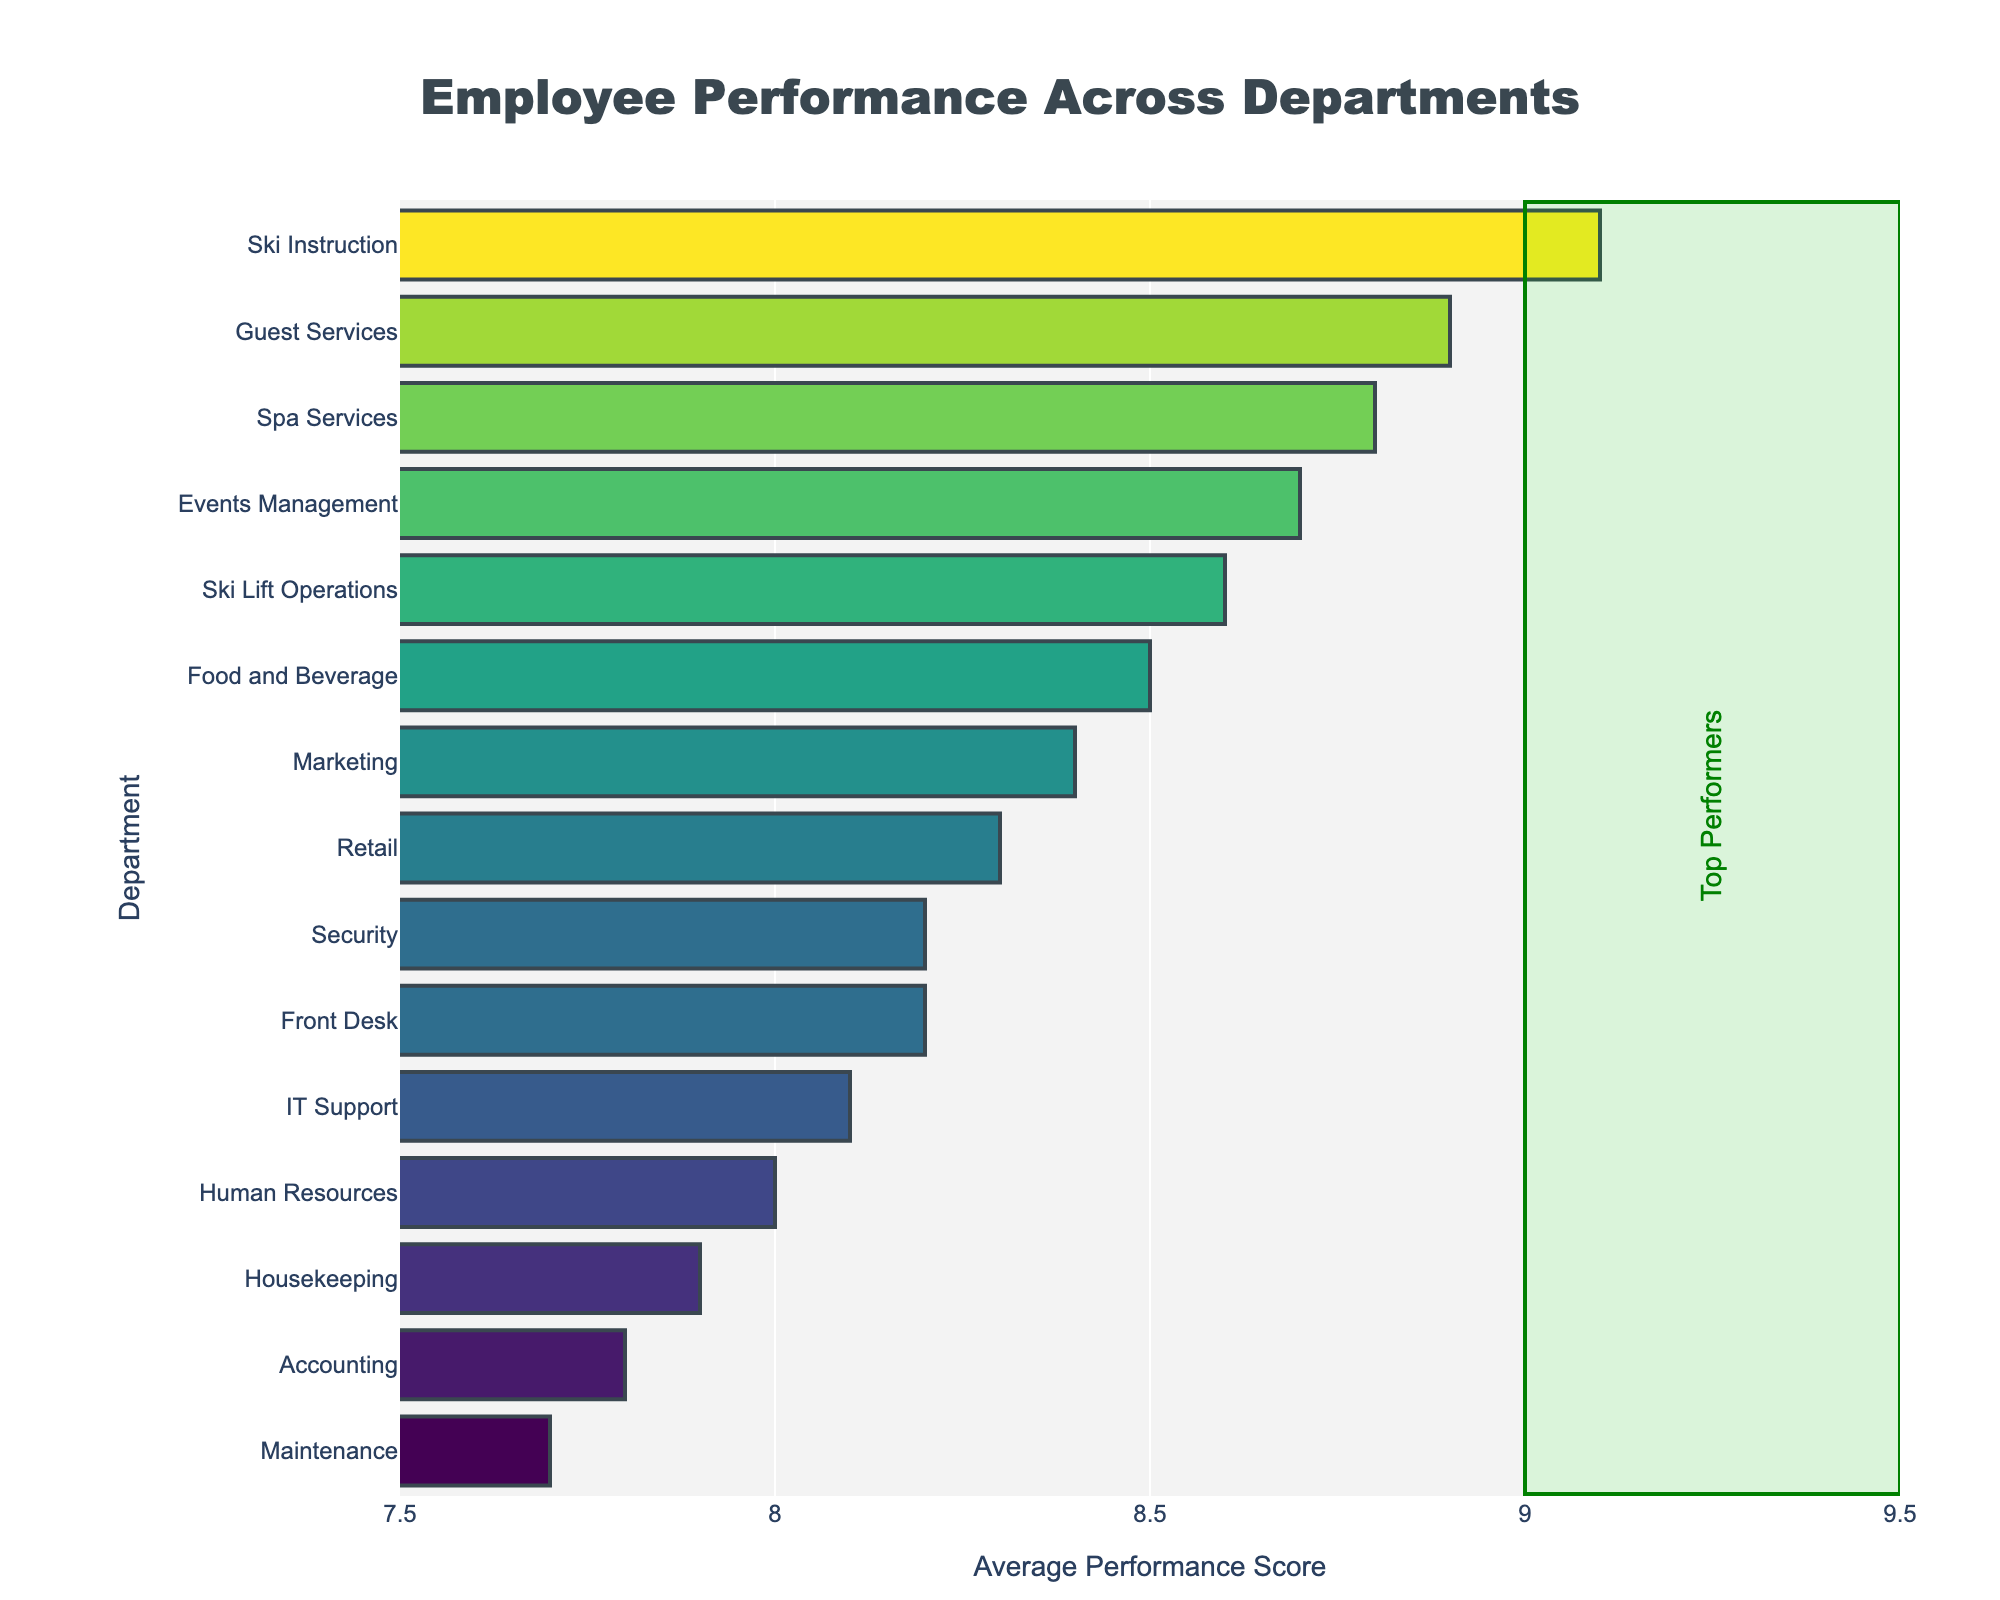Which department has the highest average performance score? Ski Instruction has the highest average performance score because, in the bar chart, it has the longest bar, and the score is highlighted as 9.1.
Answer: Ski Instruction Which department has the lowest average performance score? Maintenance has the lowest average performance score because, in the bar chart, it has the shortest bar, and the score is shown as 7.7.
Answer: Maintenance Which departments are considered top performers? Departments with average performance scores above 9 are highlighted in a green-shaded area labeled "Top Performers." These departments are Ski Instruction and Guest Services with scores of 9.1 and 8.9, respectively.
Answer: Ski Instruction, Guest Services What is the average performance score for the Retail and Spa Services departments combined? Add the scores for Retail (8.3) and Spa Services (8.8), and then divide by 2. (8.3 + 8.8) / 2 = 17.1 / 2 = 8.55
Answer: 8.55 Which department has a lower average performance score: Housekeeping or IT Support? Compare the bars: Housekeeping has a score of 7.9, and IT Support has a score of 8.1. Housekeeping's score is lower.
Answer: Housekeeping Which departments have an average performance score greater than Marketing? Marketing has a score of 8.4. The departments with higher scores are Ski Instruction (9.1), Spa Services (8.8), Guest Services (8.9), Ski Lift Operations (8.6), Events Management (8.7), Food and Beverage (8.5), and Retail (8.3).
Answer: Ski Instruction, Spa Services, Guest Services, Ski Lift Operations, Events Management, Food and Beverage, Retail What is the range of average performance scores across all departments? The range is calculated by subtracting the lowest score (Maintenance, 7.7) from the highest score (Ski Instruction, 9.1): 9.1 - 7.7 = 1.4.
Answer: 1.4 How does the performance of Human Resources compare to Accounting? Human Resources has a performance score of 8.0, and Accounting has a score of 7.8. Therefore, Human Resources scores higher than Accounting.
Answer: Human Resources Which departments are between Front Desk and Security in terms of performance score? The performance scores for Front Desk (8.2) and Security (8.2) are equal. The departments within this range are IT Support (8.1), Human Resources (8.0), and Housekeeping (7.9).
Answer: IT Support, Human Resources, Housekeeping 